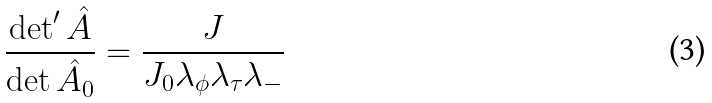Convert formula to latex. <formula><loc_0><loc_0><loc_500><loc_500>\frac { \det ^ { \prime } \hat { A } } { \det \hat { A _ { 0 } } } = \frac { J } { J _ { 0 } \lambda _ { \phi } \lambda _ { \tau } \lambda _ { - } }</formula> 